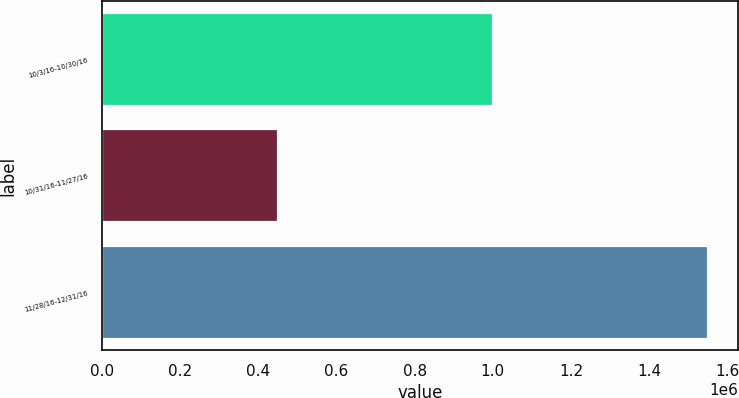<chart> <loc_0><loc_0><loc_500><loc_500><bar_chart><fcel>10/3/16-10/30/16<fcel>10/31/16-11/27/16<fcel>11/28/16-12/31/16<nl><fcel>1e+06<fcel>451300<fcel>1.55e+06<nl></chart> 